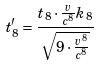<formula> <loc_0><loc_0><loc_500><loc_500>t _ { 8 } ^ { \prime } = \frac { t _ { 8 } \cdot \frac { v } { c ^ { 8 } } k _ { 8 } } { \sqrt { 9 \cdot \frac { v ^ { 8 } } { c ^ { 8 } } } }</formula> 